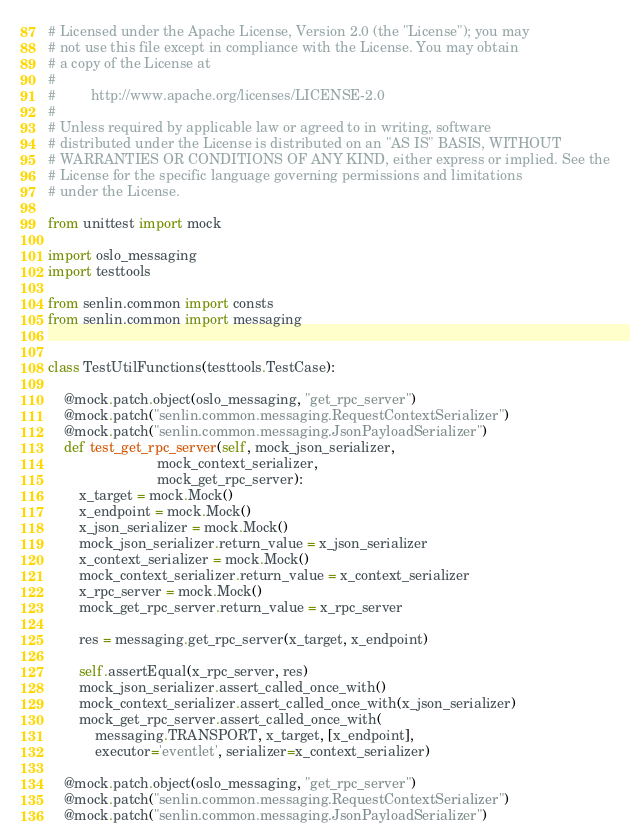Convert code to text. <code><loc_0><loc_0><loc_500><loc_500><_Python_># Licensed under the Apache License, Version 2.0 (the "License"); you may
# not use this file except in compliance with the License. You may obtain
# a copy of the License at
#
#         http://www.apache.org/licenses/LICENSE-2.0
#
# Unless required by applicable law or agreed to in writing, software
# distributed under the License is distributed on an "AS IS" BASIS, WITHOUT
# WARRANTIES OR CONDITIONS OF ANY KIND, either express or implied. See the
# License for the specific language governing permissions and limitations
# under the License.

from unittest import mock

import oslo_messaging
import testtools

from senlin.common import consts
from senlin.common import messaging


class TestUtilFunctions(testtools.TestCase):

    @mock.patch.object(oslo_messaging, "get_rpc_server")
    @mock.patch("senlin.common.messaging.RequestContextSerializer")
    @mock.patch("senlin.common.messaging.JsonPayloadSerializer")
    def test_get_rpc_server(self, mock_json_serializer,
                            mock_context_serializer,
                            mock_get_rpc_server):
        x_target = mock.Mock()
        x_endpoint = mock.Mock()
        x_json_serializer = mock.Mock()
        mock_json_serializer.return_value = x_json_serializer
        x_context_serializer = mock.Mock()
        mock_context_serializer.return_value = x_context_serializer
        x_rpc_server = mock.Mock()
        mock_get_rpc_server.return_value = x_rpc_server

        res = messaging.get_rpc_server(x_target, x_endpoint)

        self.assertEqual(x_rpc_server, res)
        mock_json_serializer.assert_called_once_with()
        mock_context_serializer.assert_called_once_with(x_json_serializer)
        mock_get_rpc_server.assert_called_once_with(
            messaging.TRANSPORT, x_target, [x_endpoint],
            executor='eventlet', serializer=x_context_serializer)

    @mock.patch.object(oslo_messaging, "get_rpc_server")
    @mock.patch("senlin.common.messaging.RequestContextSerializer")
    @mock.patch("senlin.common.messaging.JsonPayloadSerializer")</code> 